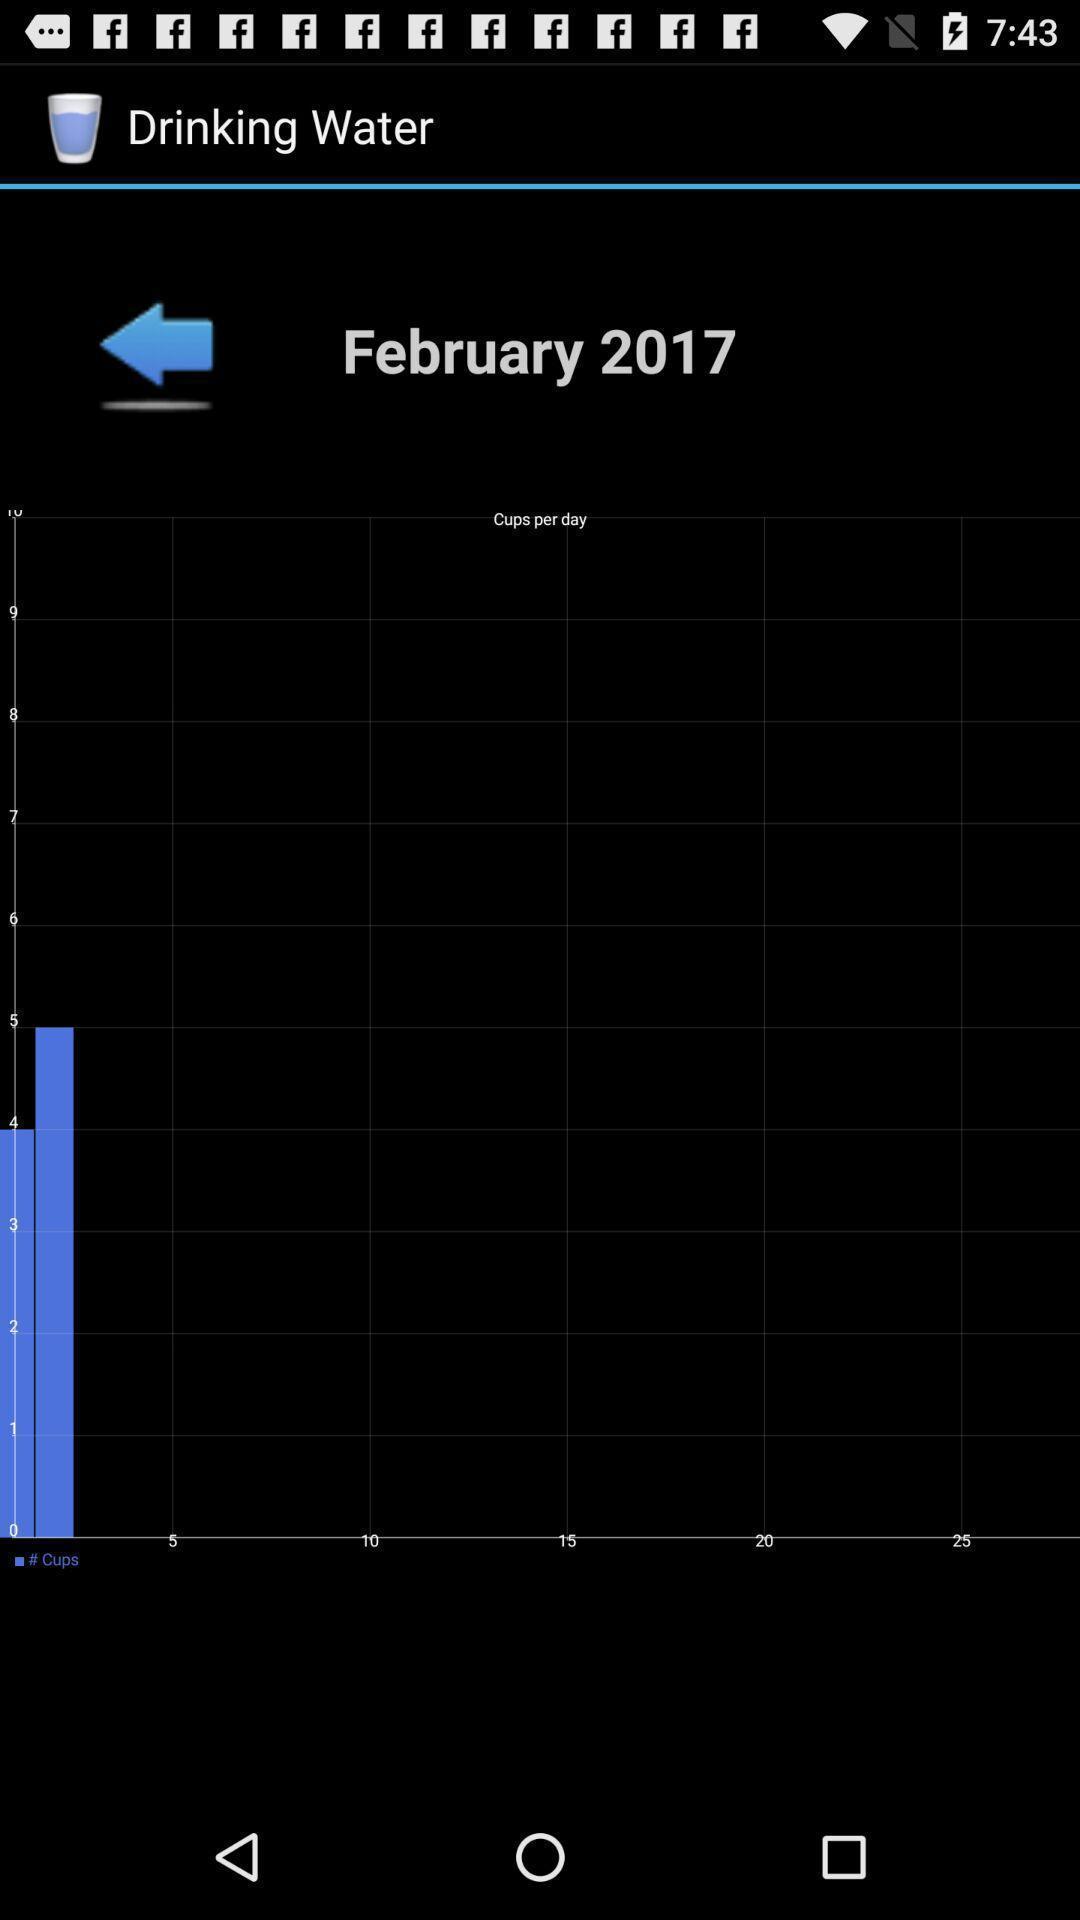Give me a summary of this screen capture. Screen showing drinking water levels per day. 